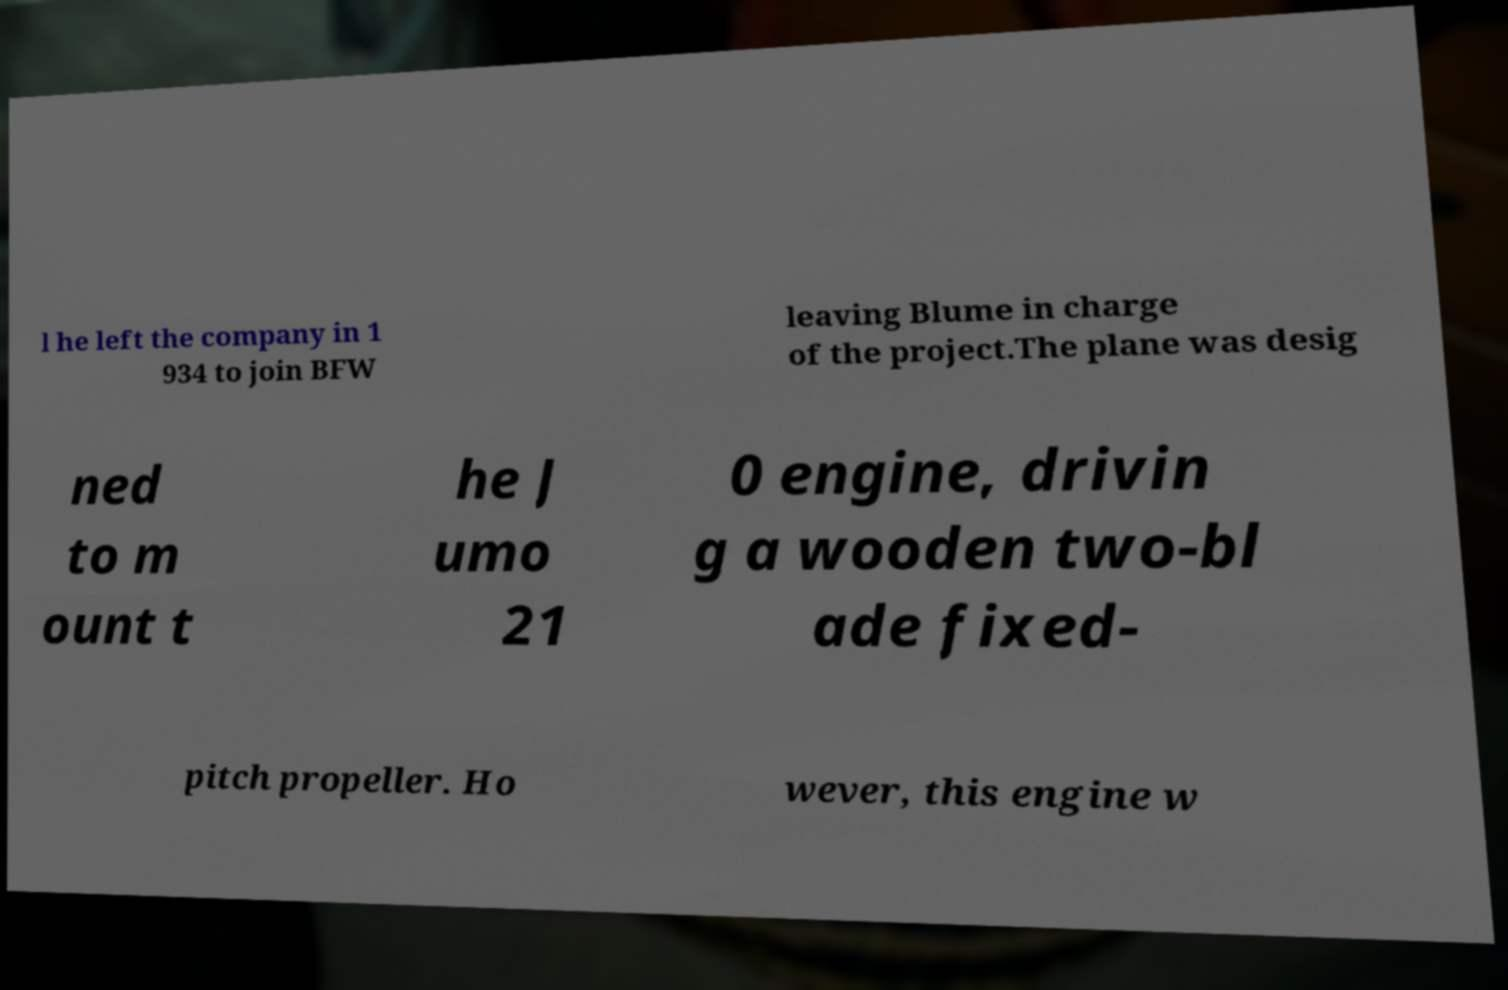For documentation purposes, I need the text within this image transcribed. Could you provide that? l he left the company in 1 934 to join BFW leaving Blume in charge of the project.The plane was desig ned to m ount t he J umo 21 0 engine, drivin g a wooden two-bl ade fixed- pitch propeller. Ho wever, this engine w 